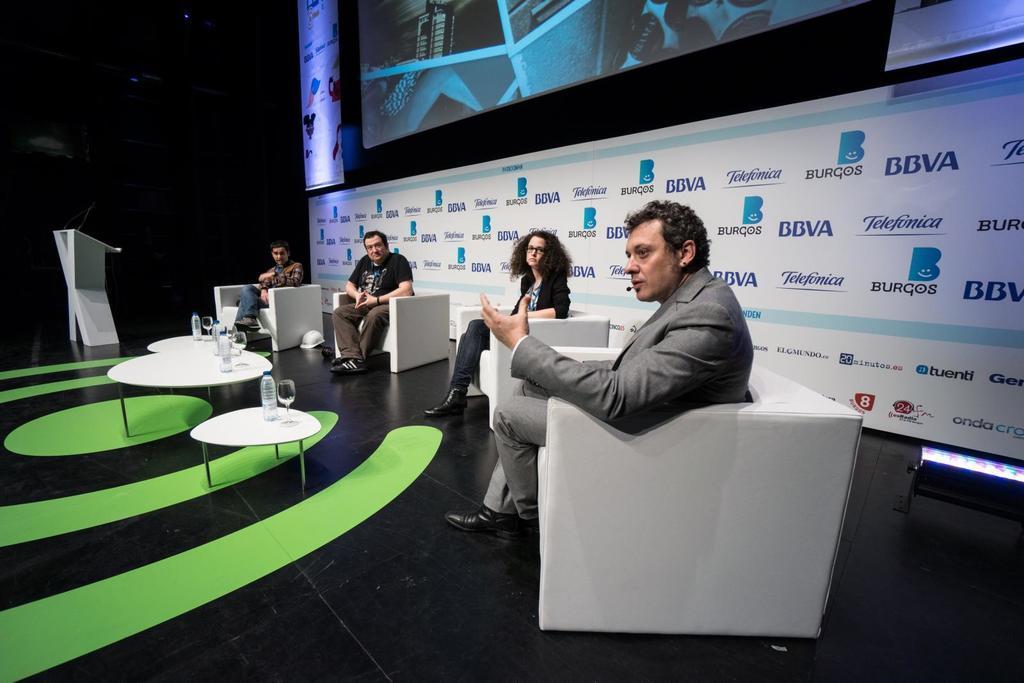Can you describe this image briefly? In this image I can see few persons sitting on couches which are white in color which are on the black colored surface. I can see few tables in front of them which are white in color and on the tables I can see few bottles and few glasses. In the background I can see a huge banner and a huge screen. 